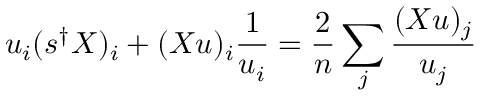Convert formula to latex. <formula><loc_0><loc_0><loc_500><loc_500>u _ { i } ( s ^ { \dagger } X ) _ { i } + ( X u ) _ { i } \frac { 1 } { u _ { i } } = \frac { 2 } { n } \sum _ { j } \frac { ( X u ) _ { j } } { u _ { j } }</formula> 